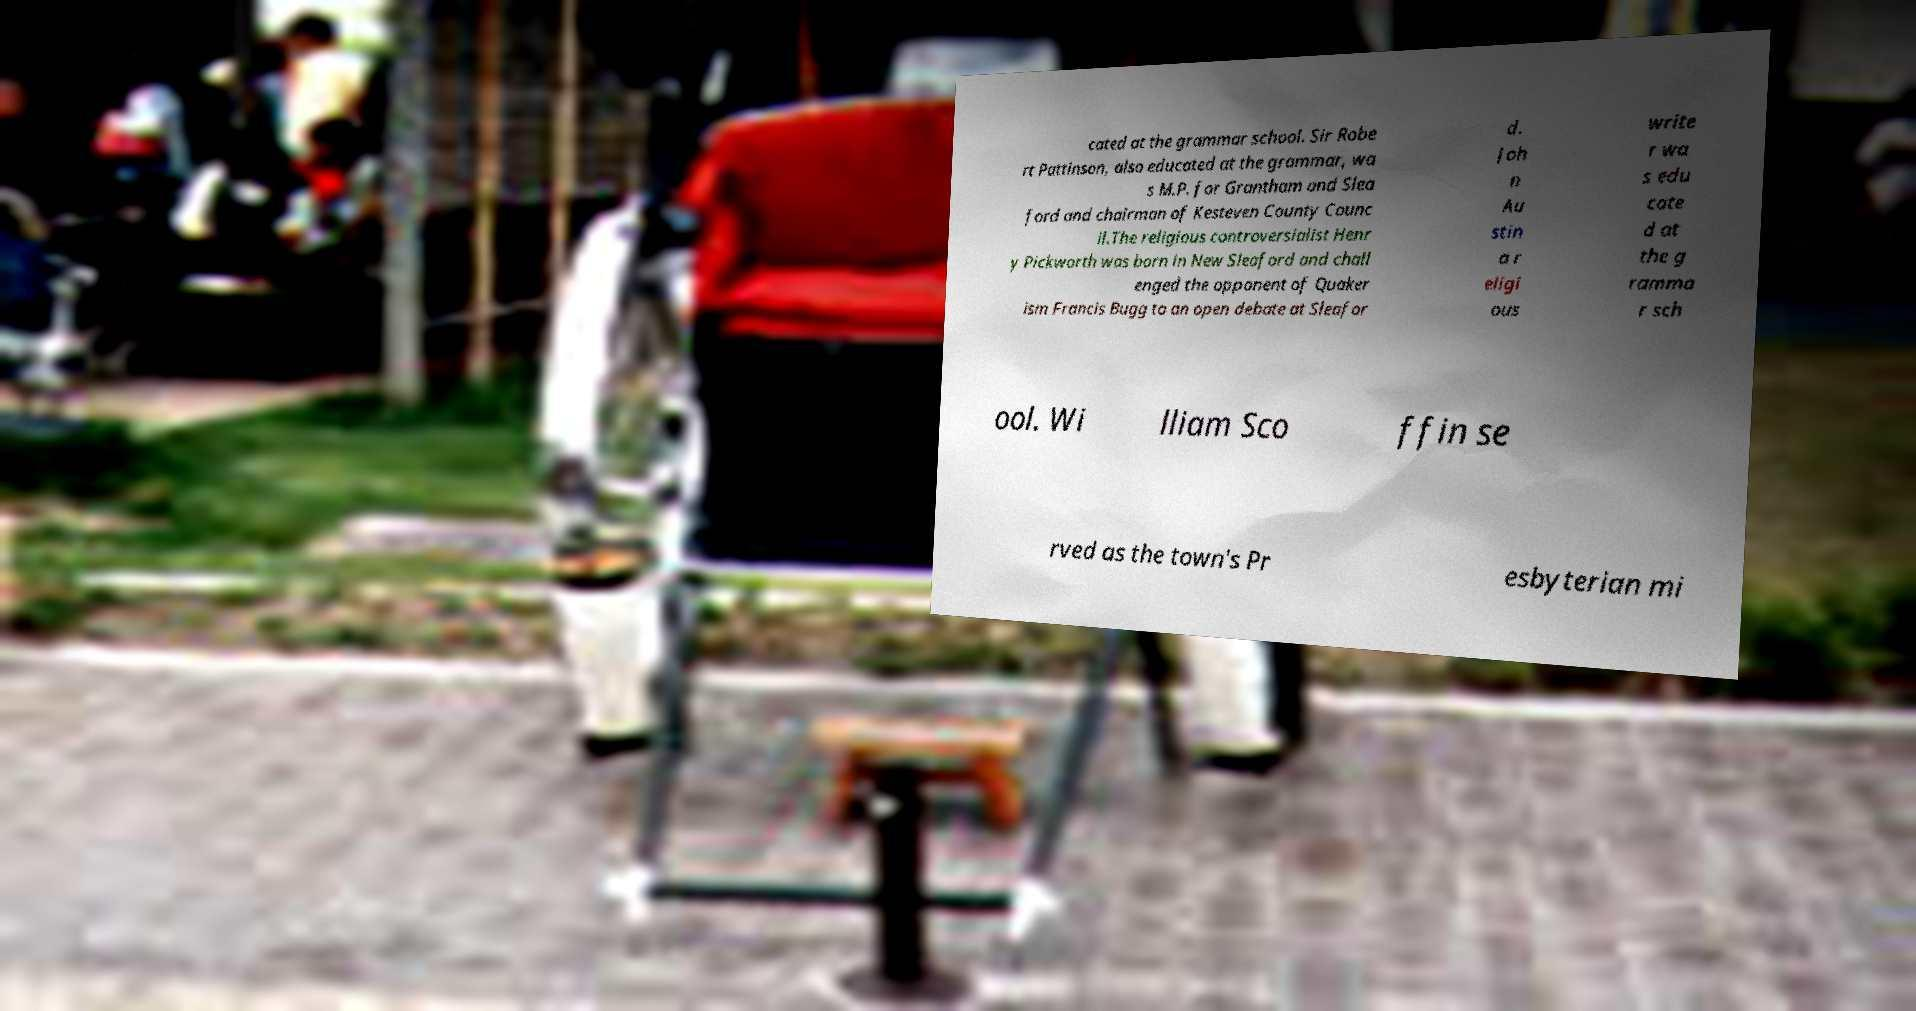I need the written content from this picture converted into text. Can you do that? cated at the grammar school. Sir Robe rt Pattinson, also educated at the grammar, wa s M.P. for Grantham and Slea ford and chairman of Kesteven County Counc il.The religious controversialist Henr y Pickworth was born in New Sleaford and chall enged the opponent of Quaker ism Francis Bugg to an open debate at Sleafor d. Joh n Au stin a r eligi ous write r wa s edu cate d at the g ramma r sch ool. Wi lliam Sco ffin se rved as the town's Pr esbyterian mi 